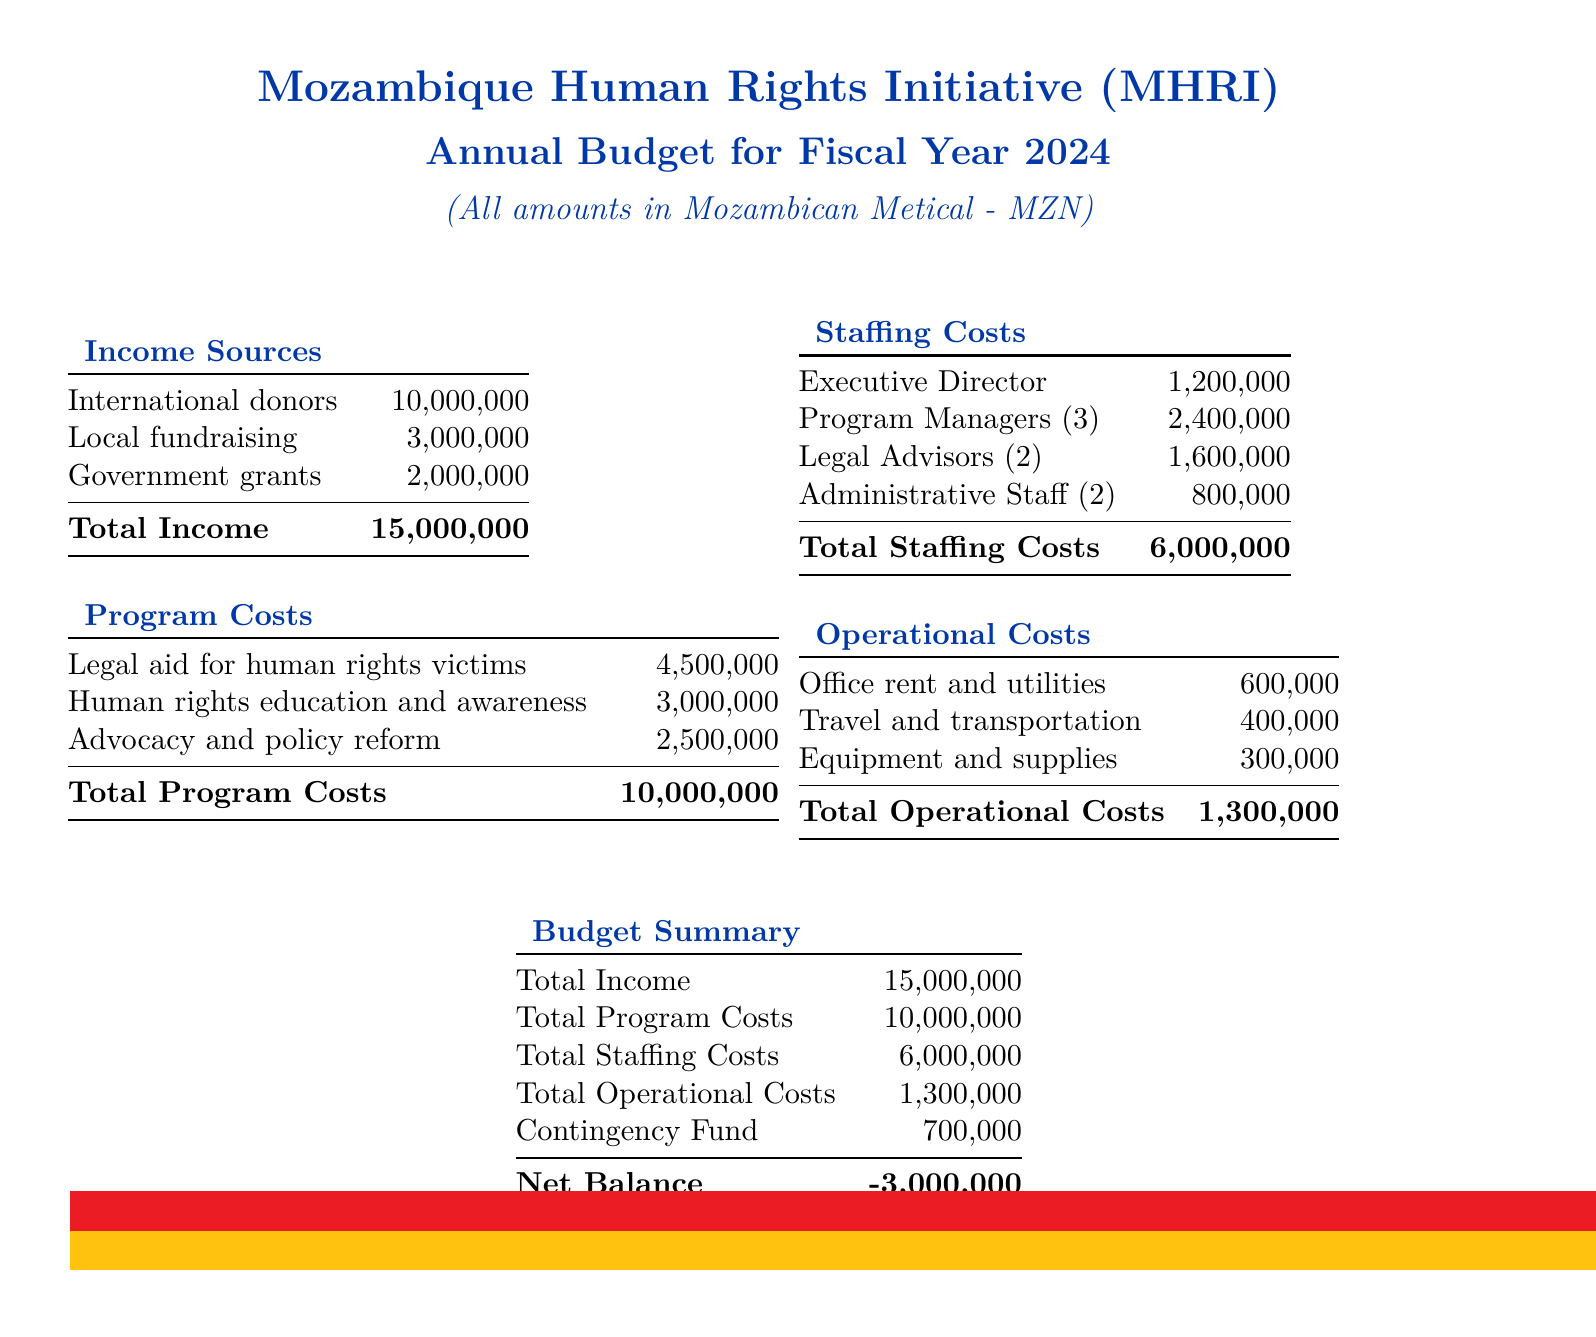what is the total income? The total income is the sum of all income sources listed in the document, which is 10,000,000 + 3,000,000 + 2,000,000 = 15,000,000.
Answer: 15,000,000 what are the total program costs? The total program costs are the sum of all program expenses in the document, which is 4,500,000 + 3,000,000 + 2,500,000 = 10,000,000.
Answer: 10,000,000 how many program managers are there? The count of program managers is specified in the staffing costs section, where it notes there are 3 program managers.
Answer: 3 what is the net balance of the budget? The net balance is calculated by subtracting the total expenses (program costs, staffing costs, operational costs, and contingency fund) from total income, which results in -3,000,000.
Answer: -3,000,000 what is the contingency fund amount? The contingency fund is listed in the budget summary section of the document, showing an allocation of 700,000.
Answer: 700,000 what is the total staffing costs? The total staffing costs are found by adding all of the staffing expenses, which are 1,200,000 + 2,400,000 + 1,600,000 + 800,000 = 6,000,000.
Answer: 6,000,000 how much is allocated for legal aid? The legal aid budget is clearly outlined as 4,500,000 in the program costs section of the document.
Answer: 4,500,000 what is the budget for travel and transportation? The budget for travel and transportation is specifically given as 400,000 in the operational costs section.
Answer: 400,000 who is the executive director? The executive director is listed as the position responsible for a cost of 1,200,000, however, their name is not provided in the budget document.
Answer: Not provided 